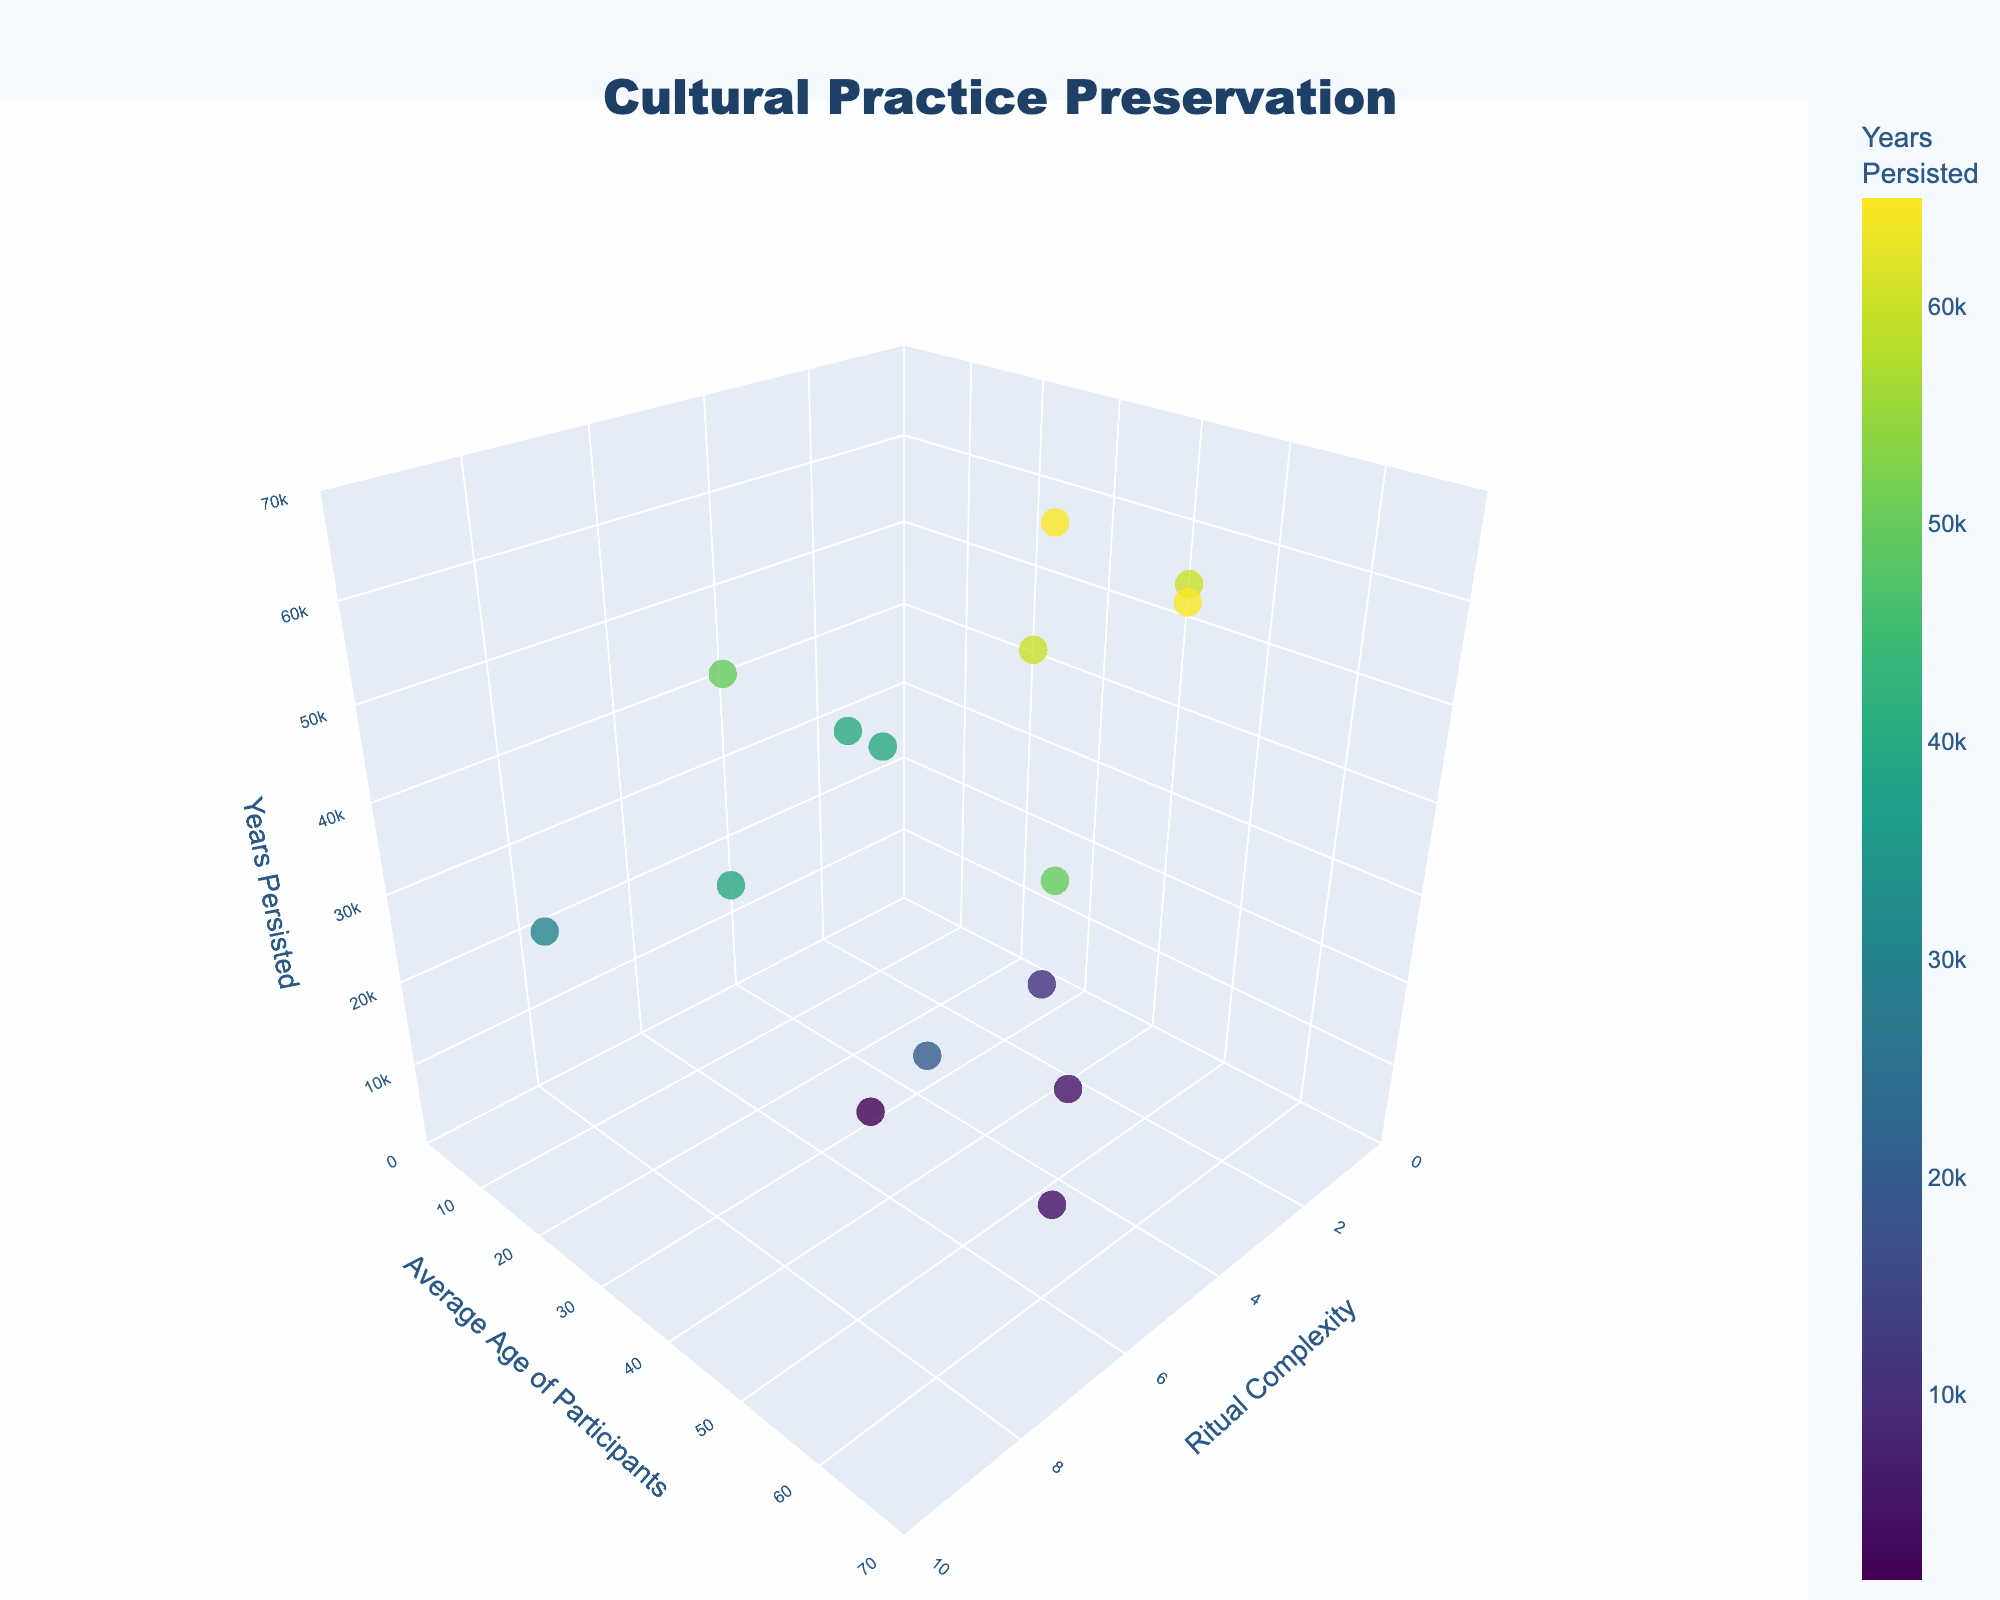How many rituals are represented in the figure? Count the number of unique data points (markers) plotted in the 3D scatter plot.
Answer: 15 What is the title of the figure? The title is displayed prominently at the top center of the figure.
Answer: Cultural Practice Preservation Which ritual has the highest average age of participants? Hover over the data points to see the ritual names and find the one with the highest y-axis value.
Answer: Songline Recitation What is the range of the 'Years Persisted' axis? Look at the z-axis labeling to determine its range.
Answer: 0 to 70,000 Which ritual has the highest complexity and how many years has it persisted? Locate the data point with the highest x-axis value and hover over it to see the ritual name and 'Years Persisted'.
Answer: Initiation Rite, 30,000 Which rituals have persisted for more than 50,000 years? Look for data points where the z-axis value is greater than 50,000 and hover to obtain their names.
Answer: Walkabout, Dreamtime Storytelling, Bush Tucker Gathering, Songline Recitation What's the average complexity of rituals with participants averaging 40 years or older? Select the data points with y-axis values of 40 or greater, sum their complexities, and divide by the number of those data points. In this case, the rituals are: Smoking Ceremony (3), Welcome to Country (2), Dreamtime Storytelling (4), Bush Tucker Gathering (3), Bark Painting (5), Boomerang Making (6), and Fire-stick Farming (5). Thus, the average complexity is (3+2+4+3+5+6+5)/7
Answer: 4.0 Which ritual has persisted the fewest years and what is its complexity? Identify the data point with the lowest z-axis value and hover to get the ritual name and complexity.
Answer: Didgeridoo Playing, 5 Is there a visible correlation between average age of participants and years persisted? Observe the general trend of data points when comparing the y-axis (Average Age) and z-axis (Years Persisted). More detailed analysis may be required, but a general observation can be made.
Answer: Generally positive correlation Which ritual has an average participant age of 35 and what is its ritual complexity? Hover over the data points with a y-axis value of 35 to find the ritual name and its x-axis value for complexity.
Answer: Corroboree, 8 